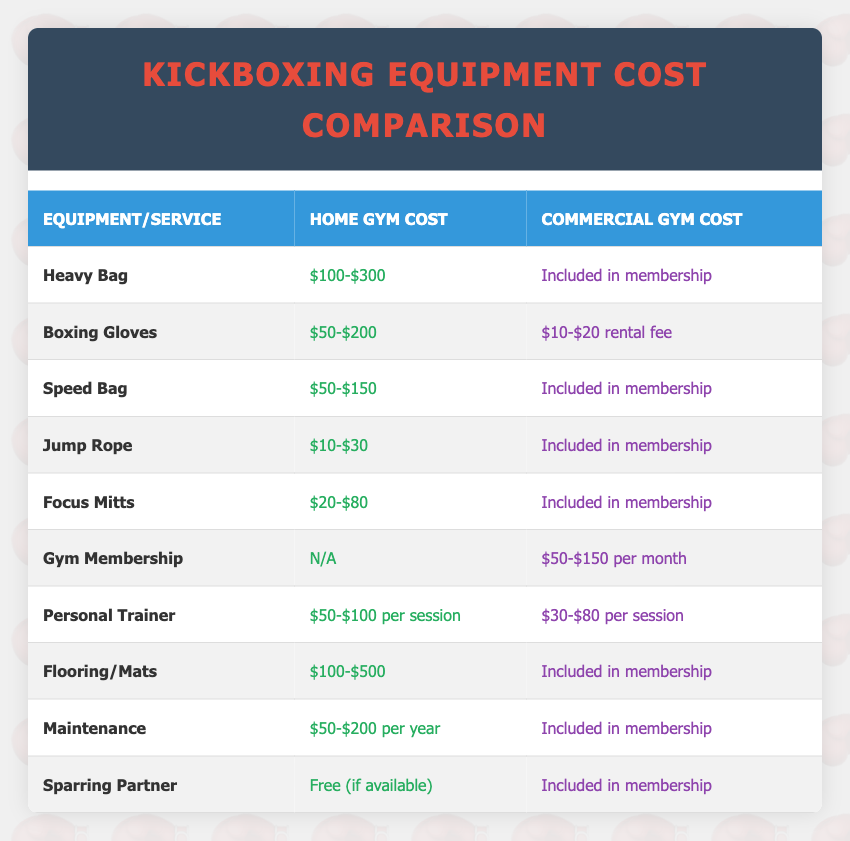What is the cost range for purchasing a heavy bag for a home gym? The table indicates that the cost range for a heavy bag in a home gym is between $100 and $300.
Answer: $100-$300 Is the cost for a jump rope included in the commercial gym membership? According to the table, the cost for a jump rope is included in the commercial gym membership.
Answer: Yes What is the average personal trainer cost for a home gym versus a commercial gym? For a home gym, the cost is between $50 and $100 per session, averaging (50+100)/2 = $75. For a commercial gym, the cost is between $30 and $80 per session, averaging (30+80)/2 = $55.
Answer: Home Gym: $75, Commercial Gym: $55 How much would it cost to set up flooring/mats in a home gym? The cost for flooring/mats for a home gym is listed as $100 to $500.
Answer: $100-$500 Is the sparring partner cost a fixed amount in a commercial gym? The data shows that a sparring partner is included in the commercial gym membership, indicating no fixed cost.
Answer: No What is the total annual cost of maintenance for a home gym? The maintenance cost for a home gym is between $50 and $200 per year. Therefore, the annual cost is variable within this range.
Answer: $50-$200 per year How much more would you spend on boxing gloves for a home gym compared to renting them at a commercial gym? The boxing gloves for a home gym cost between $50 and $200, whereas the rental cost at a commercial gym is between $10 and $20. The maximum difference is $200 - $20 = $180, and the minimum difference is $50 - $10 = $40.
Answer: $40-$180 If someone trains at a commercial gym for a year, what's the minimum total cost for gym membership only? The minimum gym membership cost listed is $50 per month, so over 12 months, the minimum total cost would be 50 * 12 = $600.
Answer: $600 Are focus mitts more expensive for a home gym compared to renting them in a commercial gym? The table shows focus mitts range from $20 to $80 for a home gym, while in a commercial gym, they are included in the membership with no explicit cost. However, since there is a rental fee for other items, it's implied that renting is cheaper.
Answer: Yes 